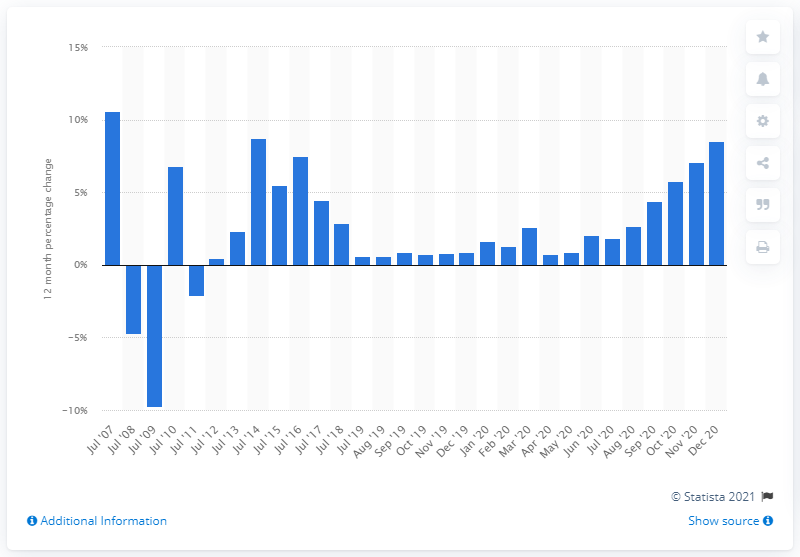Indicate a few pertinent items in this graphic. In the 12 months prior to December 2020, the average price of a house in the UK increased by 8.5%. 